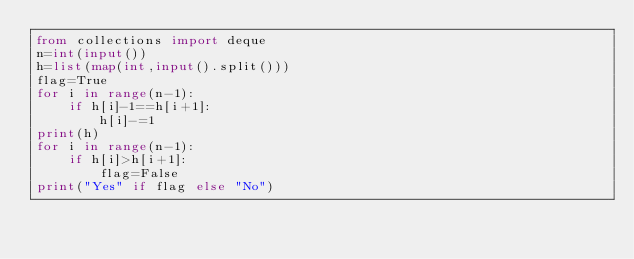Convert code to text. <code><loc_0><loc_0><loc_500><loc_500><_Python_>from collections import deque
n=int(input())
h=list(map(int,input().split()))
flag=True
for i in range(n-1):
    if h[i]-1==h[i+1]:
        h[i]-=1
print(h)
for i in range(n-1):
    if h[i]>h[i+1]:
        flag=False
print("Yes" if flag else "No")</code> 